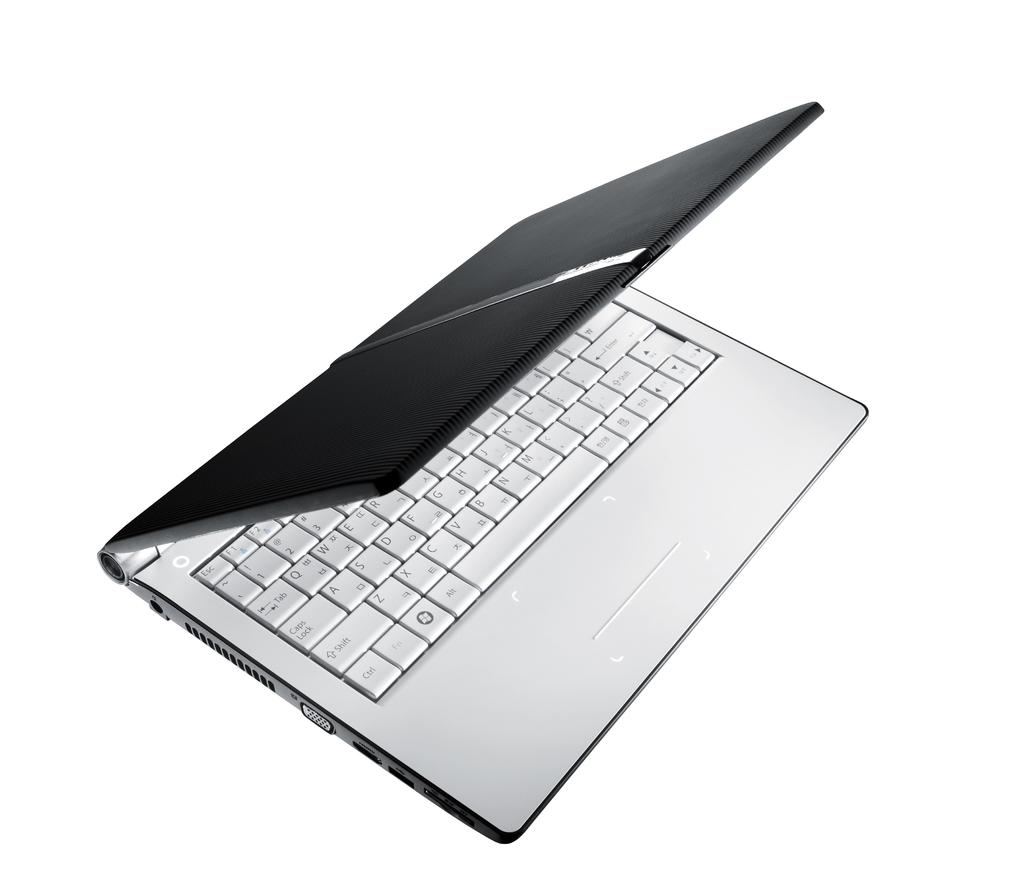<image>
Offer a succinct explanation of the picture presented. A laptop has a keyboard with a bunch of keys including shift, ctrl and caps lock. 